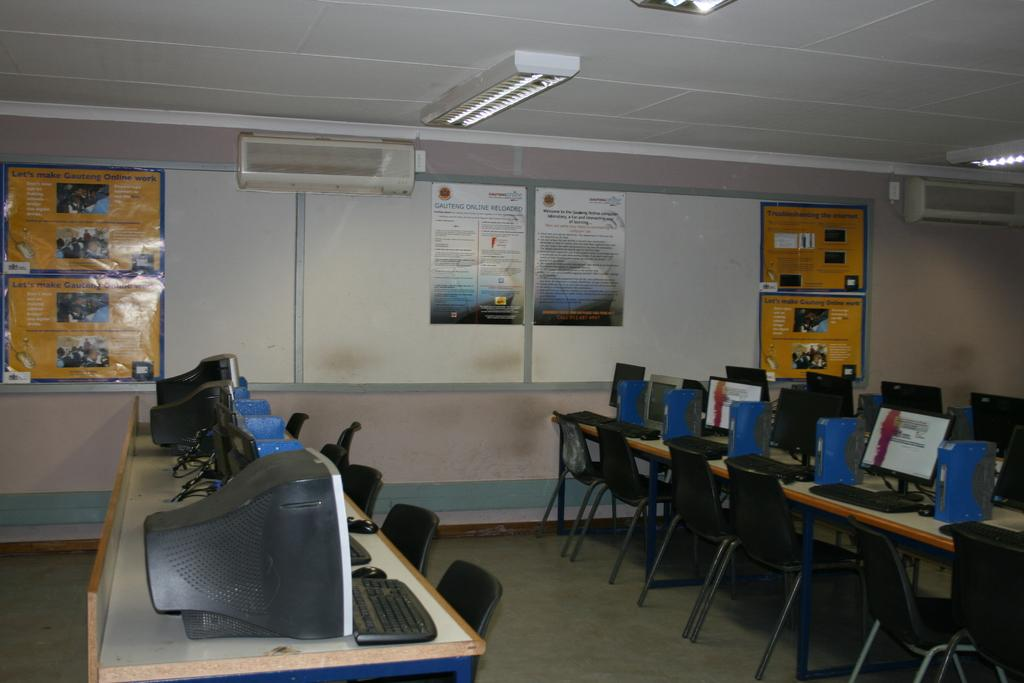What type of structure can be seen in the image? There is a wall in the image. What decorative elements are present in the image? There are banners in the image. What lighting features are visible in the image? There are lights in the image. What appliances can be seen in the image? There are air conditioners in the image. What type of furniture is present in the image? There are tables and chairs in the image. What device is used for displaying information or media in the image? There is a screen in the image. Can you see any units or tubs in the image? There are no units or tubs present in the image. Is there a cobweb visible on the wall in the image? There is no cobweb visible on the wall in the image. 